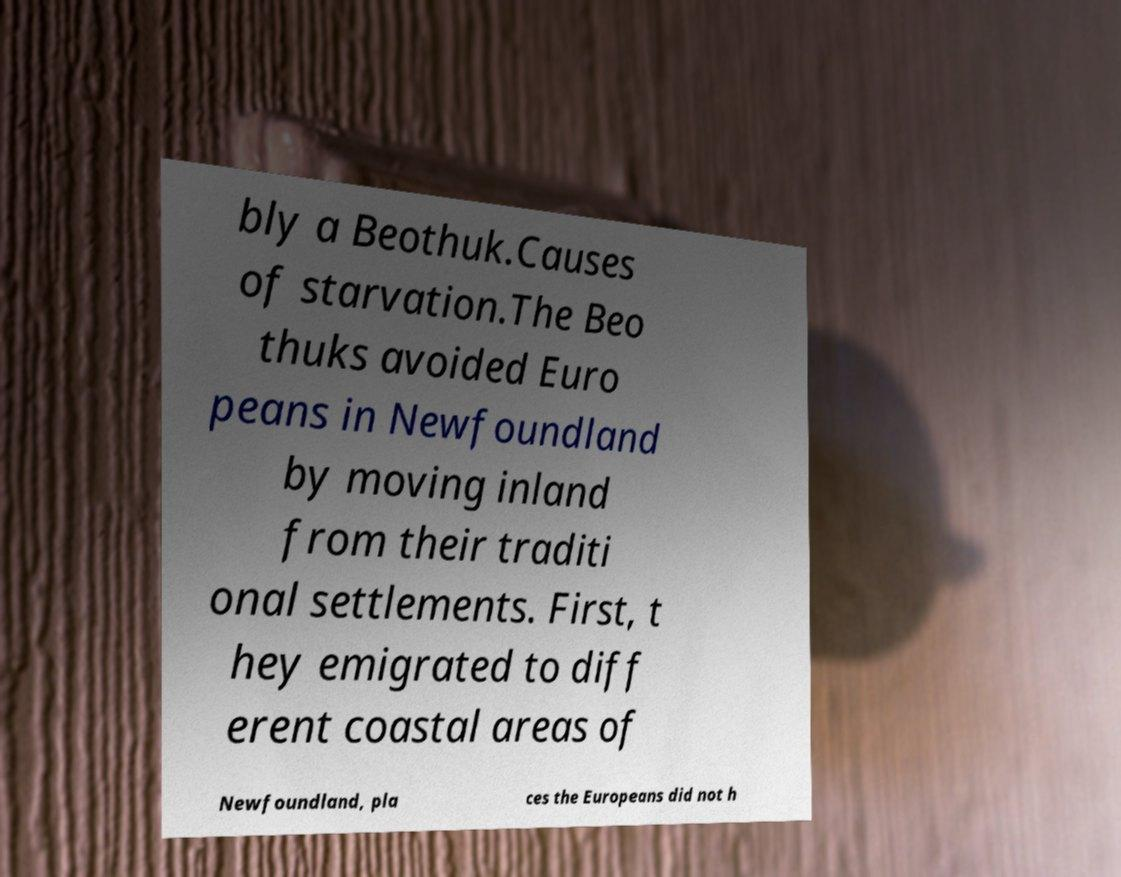Can you accurately transcribe the text from the provided image for me? bly a Beothuk.Causes of starvation.The Beo thuks avoided Euro peans in Newfoundland by moving inland from their traditi onal settlements. First, t hey emigrated to diff erent coastal areas of Newfoundland, pla ces the Europeans did not h 